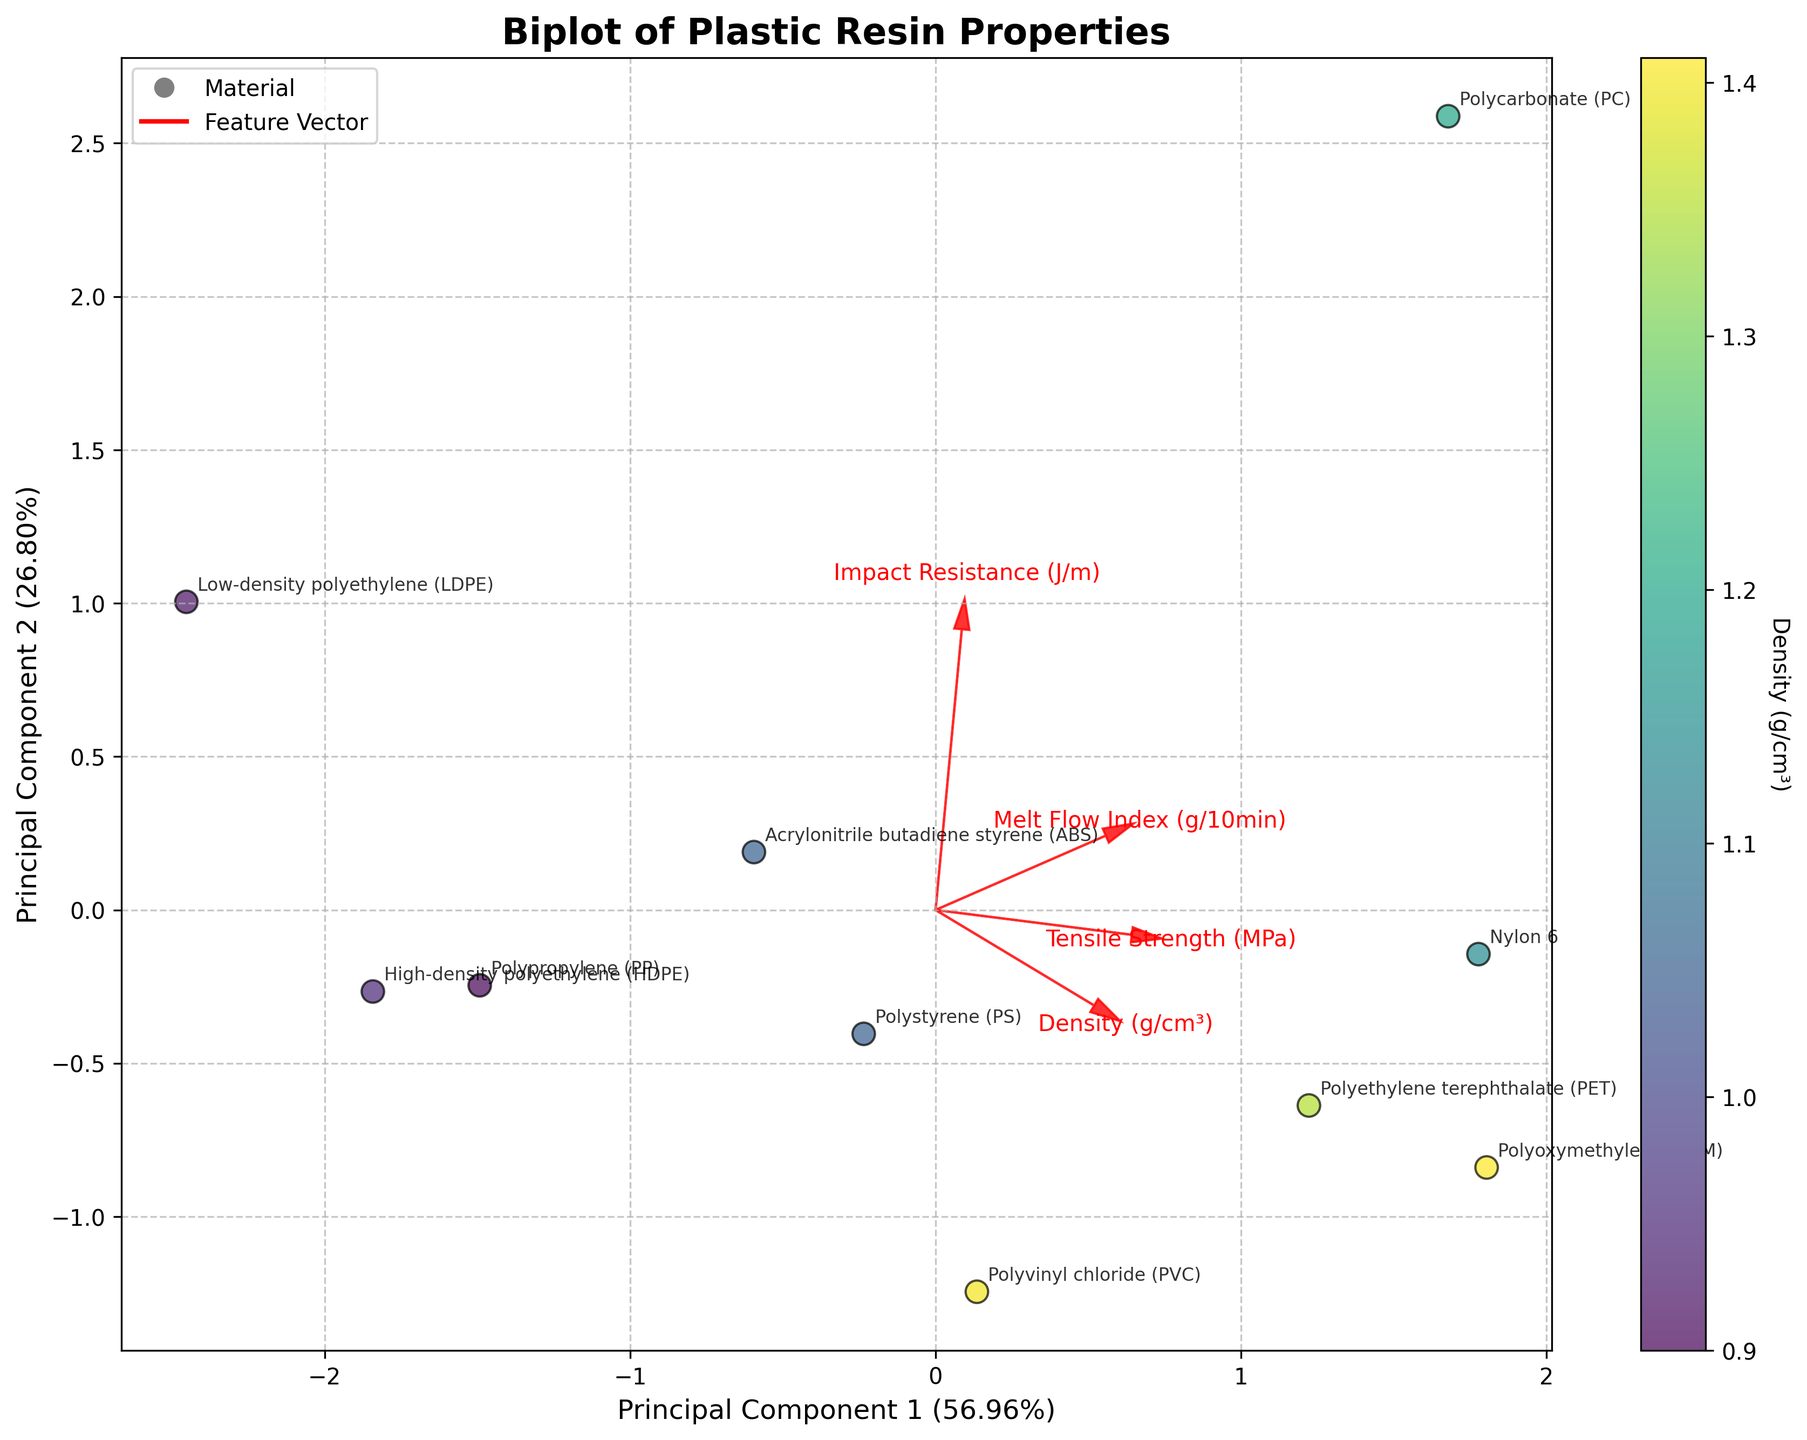What is the title of the biplot? The title of the biplot is located at the top center of the figure. By reading it, we can identify it.
Answer: Biplot of Plastic Resin Properties How many plastic materials are represented in the biplot? Each point in the biplot represents a different plastic material. By manually counting all labeled points, we can determine the total number of materials.
Answer: 10 Which material has the highest impact resistance in the biplot? By looking at the annotated points, we can find the material situated farthest in the direction of the 'Impact Resistance (J/m)' vector.
Answer: Polycarbonate (PC) What do the red arrows in the biplot represent? The red arrows represent the directions and contributions of the original features (tensile strength, impact resistance, density, and melt flow index) to the principal components.
Answer: Feature vectors Which material has both high tensile strength and high impact resistance? We need to look for a material positioned in the direction where both the 'Tensile Strength (MPa)' and the 'Impact Resistance (J/m)' vectors point.
Answer: Polycarbonate (PC) Between Nylon 6 and ABS, which material has a higher density? By observing the color of the points representing each material (both Nylon 6 and ABS) and referring to the color bar, we can deduce their densities.
Answer: ABS Which material differs the most from HDPE in terms of the PCA components? By examining the distance between the points for HDPE and other materials in the biplot, we can identify which one is farthest from HDPE.
Answer: Polycarbonate (PC) What percentage of variance is explained by the first principal component (PC1)? The percentage of variance explained by PC1 is written along the x-axis label.
Answer: Approximately 55% Are there any materials that are close in PCA space but might be different in other features? We need to identify clusters of points in the biplot that are close to each other to assess if different features are contributing to similarities in PCA space.
Answer: Yes Which materials have low melt flow index but are not close in the PCA plot? We need to look at the direction of the 'Melt Flow Index (g/10min)' vector and identify points on opposite sides of this vector.
Answer: HDPE and Polycarbonate (PC) 